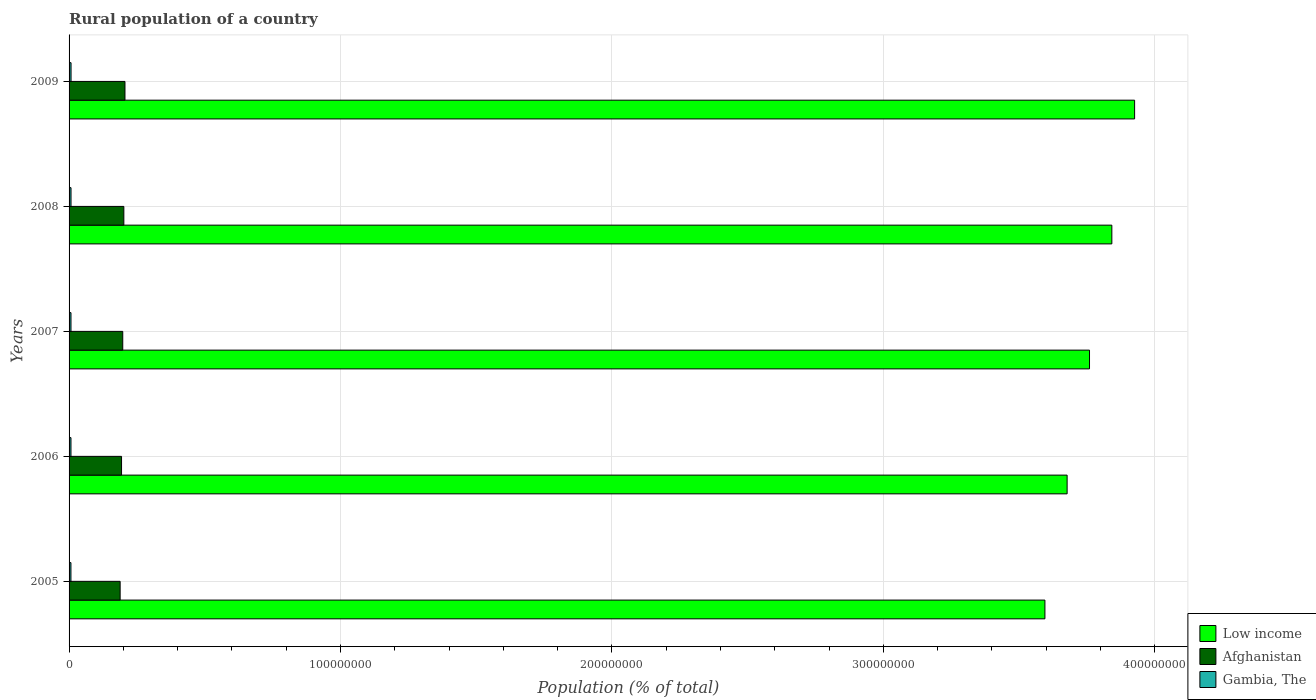How many groups of bars are there?
Your answer should be very brief. 5. Are the number of bars per tick equal to the number of legend labels?
Provide a short and direct response. Yes. Are the number of bars on each tick of the Y-axis equal?
Offer a terse response. Yes. How many bars are there on the 3rd tick from the top?
Keep it short and to the point. 3. How many bars are there on the 2nd tick from the bottom?
Keep it short and to the point. 3. What is the label of the 3rd group of bars from the top?
Your answer should be compact. 2007. What is the rural population in Gambia, The in 2007?
Your answer should be compact. 7.07e+05. Across all years, what is the maximum rural population in Gambia, The?
Keep it short and to the point. 7.28e+05. Across all years, what is the minimum rural population in Afghanistan?
Offer a very short reply. 1.88e+07. In which year was the rural population in Afghanistan minimum?
Provide a short and direct response. 2005. What is the total rural population in Low income in the graph?
Ensure brevity in your answer.  1.88e+09. What is the difference between the rural population in Gambia, The in 2006 and that in 2008?
Your answer should be compact. -2.09e+04. What is the difference between the rural population in Afghanistan in 2005 and the rural population in Low income in 2007?
Provide a short and direct response. -3.57e+08. What is the average rural population in Afghanistan per year?
Keep it short and to the point. 1.97e+07. In the year 2007, what is the difference between the rural population in Afghanistan and rural population in Gambia, The?
Provide a short and direct response. 1.91e+07. In how many years, is the rural population in Low income greater than 320000000 %?
Offer a terse response. 5. What is the ratio of the rural population in Gambia, The in 2006 to that in 2007?
Give a very brief answer. 0.99. Is the rural population in Low income in 2007 less than that in 2009?
Provide a succinct answer. Yes. Is the difference between the rural population in Afghanistan in 2006 and 2008 greater than the difference between the rural population in Gambia, The in 2006 and 2008?
Offer a very short reply. No. What is the difference between the highest and the second highest rural population in Afghanistan?
Give a very brief answer. 4.16e+05. What is the difference between the highest and the lowest rural population in Low income?
Ensure brevity in your answer.  3.30e+07. Is the sum of the rural population in Afghanistan in 2007 and 2009 greater than the maximum rural population in Low income across all years?
Provide a short and direct response. No. What does the 1st bar from the top in 2008 represents?
Give a very brief answer. Gambia, The. What does the 2nd bar from the bottom in 2008 represents?
Your response must be concise. Afghanistan. Is it the case that in every year, the sum of the rural population in Low income and rural population in Afghanistan is greater than the rural population in Gambia, The?
Keep it short and to the point. Yes. How many bars are there?
Make the answer very short. 15. Are all the bars in the graph horizontal?
Keep it short and to the point. Yes. How many years are there in the graph?
Your answer should be very brief. 5. Are the values on the major ticks of X-axis written in scientific E-notation?
Make the answer very short. No. Does the graph contain any zero values?
Offer a very short reply. No. Does the graph contain grids?
Give a very brief answer. Yes. How many legend labels are there?
Your answer should be very brief. 3. How are the legend labels stacked?
Offer a very short reply. Vertical. What is the title of the graph?
Give a very brief answer. Rural population of a country. Does "Fiji" appear as one of the legend labels in the graph?
Offer a terse response. No. What is the label or title of the X-axis?
Provide a succinct answer. Population (% of total). What is the Population (% of total) of Low income in 2005?
Ensure brevity in your answer.  3.60e+08. What is the Population (% of total) in Afghanistan in 2005?
Your response must be concise. 1.88e+07. What is the Population (% of total) in Gambia, The in 2005?
Make the answer very short. 6.87e+05. What is the Population (% of total) of Low income in 2006?
Give a very brief answer. 3.68e+08. What is the Population (% of total) in Afghanistan in 2006?
Ensure brevity in your answer.  1.93e+07. What is the Population (% of total) of Gambia, The in 2006?
Offer a terse response. 6.97e+05. What is the Population (% of total) in Low income in 2007?
Your answer should be very brief. 3.76e+08. What is the Population (% of total) in Afghanistan in 2007?
Ensure brevity in your answer.  1.98e+07. What is the Population (% of total) of Gambia, The in 2007?
Make the answer very short. 7.07e+05. What is the Population (% of total) of Low income in 2008?
Your answer should be compact. 3.84e+08. What is the Population (% of total) in Afghanistan in 2008?
Give a very brief answer. 2.02e+07. What is the Population (% of total) in Gambia, The in 2008?
Your answer should be very brief. 7.17e+05. What is the Population (% of total) of Low income in 2009?
Offer a very short reply. 3.93e+08. What is the Population (% of total) in Afghanistan in 2009?
Your answer should be compact. 2.06e+07. What is the Population (% of total) of Gambia, The in 2009?
Your response must be concise. 7.28e+05. Across all years, what is the maximum Population (% of total) in Low income?
Offer a terse response. 3.93e+08. Across all years, what is the maximum Population (% of total) of Afghanistan?
Provide a succinct answer. 2.06e+07. Across all years, what is the maximum Population (% of total) of Gambia, The?
Make the answer very short. 7.28e+05. Across all years, what is the minimum Population (% of total) of Low income?
Provide a succinct answer. 3.60e+08. Across all years, what is the minimum Population (% of total) of Afghanistan?
Provide a short and direct response. 1.88e+07. Across all years, what is the minimum Population (% of total) in Gambia, The?
Ensure brevity in your answer.  6.87e+05. What is the total Population (% of total) in Low income in the graph?
Provide a short and direct response. 1.88e+09. What is the total Population (% of total) of Afghanistan in the graph?
Ensure brevity in your answer.  9.87e+07. What is the total Population (% of total) of Gambia, The in the graph?
Provide a short and direct response. 3.54e+06. What is the difference between the Population (% of total) of Low income in 2005 and that in 2006?
Offer a terse response. -8.17e+06. What is the difference between the Population (% of total) of Afghanistan in 2005 and that in 2006?
Provide a succinct answer. -5.18e+05. What is the difference between the Population (% of total) in Gambia, The in 2005 and that in 2006?
Offer a terse response. -9992. What is the difference between the Population (% of total) of Low income in 2005 and that in 2007?
Your answer should be very brief. -1.64e+07. What is the difference between the Population (% of total) of Afghanistan in 2005 and that in 2007?
Give a very brief answer. -9.60e+05. What is the difference between the Population (% of total) of Gambia, The in 2005 and that in 2007?
Your answer should be compact. -2.03e+04. What is the difference between the Population (% of total) of Low income in 2005 and that in 2008?
Ensure brevity in your answer.  -2.47e+07. What is the difference between the Population (% of total) of Afghanistan in 2005 and that in 2008?
Your response must be concise. -1.36e+06. What is the difference between the Population (% of total) in Gambia, The in 2005 and that in 2008?
Provide a short and direct response. -3.09e+04. What is the difference between the Population (% of total) in Low income in 2005 and that in 2009?
Ensure brevity in your answer.  -3.30e+07. What is the difference between the Population (% of total) of Afghanistan in 2005 and that in 2009?
Make the answer very short. -1.78e+06. What is the difference between the Population (% of total) of Gambia, The in 2005 and that in 2009?
Your response must be concise. -4.19e+04. What is the difference between the Population (% of total) in Low income in 2006 and that in 2007?
Provide a short and direct response. -8.25e+06. What is the difference between the Population (% of total) of Afghanistan in 2006 and that in 2007?
Your answer should be very brief. -4.42e+05. What is the difference between the Population (% of total) of Gambia, The in 2006 and that in 2007?
Your answer should be compact. -1.03e+04. What is the difference between the Population (% of total) of Low income in 2006 and that in 2008?
Offer a very short reply. -1.65e+07. What is the difference between the Population (% of total) of Afghanistan in 2006 and that in 2008?
Ensure brevity in your answer.  -8.44e+05. What is the difference between the Population (% of total) in Gambia, The in 2006 and that in 2008?
Offer a very short reply. -2.09e+04. What is the difference between the Population (% of total) in Low income in 2006 and that in 2009?
Provide a succinct answer. -2.49e+07. What is the difference between the Population (% of total) of Afghanistan in 2006 and that in 2009?
Your answer should be compact. -1.26e+06. What is the difference between the Population (% of total) of Gambia, The in 2006 and that in 2009?
Your response must be concise. -3.19e+04. What is the difference between the Population (% of total) of Low income in 2007 and that in 2008?
Offer a very short reply. -8.23e+06. What is the difference between the Population (% of total) of Afghanistan in 2007 and that in 2008?
Your response must be concise. -4.02e+05. What is the difference between the Population (% of total) of Gambia, The in 2007 and that in 2008?
Provide a short and direct response. -1.06e+04. What is the difference between the Population (% of total) in Low income in 2007 and that in 2009?
Offer a terse response. -1.66e+07. What is the difference between the Population (% of total) in Afghanistan in 2007 and that in 2009?
Your answer should be very brief. -8.19e+05. What is the difference between the Population (% of total) in Gambia, The in 2007 and that in 2009?
Your answer should be very brief. -2.16e+04. What is the difference between the Population (% of total) in Low income in 2008 and that in 2009?
Offer a very short reply. -8.38e+06. What is the difference between the Population (% of total) in Afghanistan in 2008 and that in 2009?
Give a very brief answer. -4.16e+05. What is the difference between the Population (% of total) in Gambia, The in 2008 and that in 2009?
Your answer should be very brief. -1.10e+04. What is the difference between the Population (% of total) in Low income in 2005 and the Population (% of total) in Afghanistan in 2006?
Make the answer very short. 3.40e+08. What is the difference between the Population (% of total) in Low income in 2005 and the Population (% of total) in Gambia, The in 2006?
Ensure brevity in your answer.  3.59e+08. What is the difference between the Population (% of total) of Afghanistan in 2005 and the Population (% of total) of Gambia, The in 2006?
Offer a terse response. 1.81e+07. What is the difference between the Population (% of total) in Low income in 2005 and the Population (% of total) in Afghanistan in 2007?
Your response must be concise. 3.40e+08. What is the difference between the Population (% of total) in Low income in 2005 and the Population (% of total) in Gambia, The in 2007?
Make the answer very short. 3.59e+08. What is the difference between the Population (% of total) in Afghanistan in 2005 and the Population (% of total) in Gambia, The in 2007?
Make the answer very short. 1.81e+07. What is the difference between the Population (% of total) in Low income in 2005 and the Population (% of total) in Afghanistan in 2008?
Ensure brevity in your answer.  3.39e+08. What is the difference between the Population (% of total) of Low income in 2005 and the Population (% of total) of Gambia, The in 2008?
Keep it short and to the point. 3.59e+08. What is the difference between the Population (% of total) in Afghanistan in 2005 and the Population (% of total) in Gambia, The in 2008?
Make the answer very short. 1.81e+07. What is the difference between the Population (% of total) of Low income in 2005 and the Population (% of total) of Afghanistan in 2009?
Your answer should be very brief. 3.39e+08. What is the difference between the Population (% of total) of Low income in 2005 and the Population (% of total) of Gambia, The in 2009?
Give a very brief answer. 3.59e+08. What is the difference between the Population (% of total) of Afghanistan in 2005 and the Population (% of total) of Gambia, The in 2009?
Offer a terse response. 1.81e+07. What is the difference between the Population (% of total) of Low income in 2006 and the Population (% of total) of Afghanistan in 2007?
Your answer should be compact. 3.48e+08. What is the difference between the Population (% of total) in Low income in 2006 and the Population (% of total) in Gambia, The in 2007?
Your response must be concise. 3.67e+08. What is the difference between the Population (% of total) of Afghanistan in 2006 and the Population (% of total) of Gambia, The in 2007?
Give a very brief answer. 1.86e+07. What is the difference between the Population (% of total) in Low income in 2006 and the Population (% of total) in Afghanistan in 2008?
Provide a short and direct response. 3.48e+08. What is the difference between the Population (% of total) in Low income in 2006 and the Population (% of total) in Gambia, The in 2008?
Offer a very short reply. 3.67e+08. What is the difference between the Population (% of total) of Afghanistan in 2006 and the Population (% of total) of Gambia, The in 2008?
Keep it short and to the point. 1.86e+07. What is the difference between the Population (% of total) of Low income in 2006 and the Population (% of total) of Afghanistan in 2009?
Your response must be concise. 3.47e+08. What is the difference between the Population (% of total) in Low income in 2006 and the Population (% of total) in Gambia, The in 2009?
Keep it short and to the point. 3.67e+08. What is the difference between the Population (% of total) of Afghanistan in 2006 and the Population (% of total) of Gambia, The in 2009?
Your answer should be compact. 1.86e+07. What is the difference between the Population (% of total) in Low income in 2007 and the Population (% of total) in Afghanistan in 2008?
Provide a succinct answer. 3.56e+08. What is the difference between the Population (% of total) of Low income in 2007 and the Population (% of total) of Gambia, The in 2008?
Provide a short and direct response. 3.75e+08. What is the difference between the Population (% of total) of Afghanistan in 2007 and the Population (% of total) of Gambia, The in 2008?
Offer a very short reply. 1.91e+07. What is the difference between the Population (% of total) of Low income in 2007 and the Population (% of total) of Afghanistan in 2009?
Ensure brevity in your answer.  3.55e+08. What is the difference between the Population (% of total) of Low income in 2007 and the Population (% of total) of Gambia, The in 2009?
Offer a very short reply. 3.75e+08. What is the difference between the Population (% of total) of Afghanistan in 2007 and the Population (% of total) of Gambia, The in 2009?
Make the answer very short. 1.90e+07. What is the difference between the Population (% of total) in Low income in 2008 and the Population (% of total) in Afghanistan in 2009?
Keep it short and to the point. 3.64e+08. What is the difference between the Population (% of total) in Low income in 2008 and the Population (% of total) in Gambia, The in 2009?
Offer a terse response. 3.83e+08. What is the difference between the Population (% of total) in Afghanistan in 2008 and the Population (% of total) in Gambia, The in 2009?
Give a very brief answer. 1.94e+07. What is the average Population (% of total) in Low income per year?
Your answer should be compact. 3.76e+08. What is the average Population (% of total) in Afghanistan per year?
Offer a very short reply. 1.97e+07. What is the average Population (% of total) in Gambia, The per year?
Make the answer very short. 7.07e+05. In the year 2005, what is the difference between the Population (% of total) in Low income and Population (% of total) in Afghanistan?
Give a very brief answer. 3.41e+08. In the year 2005, what is the difference between the Population (% of total) of Low income and Population (% of total) of Gambia, The?
Give a very brief answer. 3.59e+08. In the year 2005, what is the difference between the Population (% of total) in Afghanistan and Population (% of total) in Gambia, The?
Provide a succinct answer. 1.81e+07. In the year 2006, what is the difference between the Population (% of total) in Low income and Population (% of total) in Afghanistan?
Your answer should be very brief. 3.48e+08. In the year 2006, what is the difference between the Population (% of total) of Low income and Population (% of total) of Gambia, The?
Ensure brevity in your answer.  3.67e+08. In the year 2006, what is the difference between the Population (% of total) of Afghanistan and Population (% of total) of Gambia, The?
Ensure brevity in your answer.  1.86e+07. In the year 2007, what is the difference between the Population (% of total) of Low income and Population (% of total) of Afghanistan?
Your answer should be very brief. 3.56e+08. In the year 2007, what is the difference between the Population (% of total) in Low income and Population (% of total) in Gambia, The?
Keep it short and to the point. 3.75e+08. In the year 2007, what is the difference between the Population (% of total) of Afghanistan and Population (% of total) of Gambia, The?
Keep it short and to the point. 1.91e+07. In the year 2008, what is the difference between the Population (% of total) of Low income and Population (% of total) of Afghanistan?
Keep it short and to the point. 3.64e+08. In the year 2008, what is the difference between the Population (% of total) of Low income and Population (% of total) of Gambia, The?
Provide a succinct answer. 3.83e+08. In the year 2008, what is the difference between the Population (% of total) in Afghanistan and Population (% of total) in Gambia, The?
Provide a short and direct response. 1.95e+07. In the year 2009, what is the difference between the Population (% of total) of Low income and Population (% of total) of Afghanistan?
Make the answer very short. 3.72e+08. In the year 2009, what is the difference between the Population (% of total) of Low income and Population (% of total) of Gambia, The?
Provide a succinct answer. 3.92e+08. In the year 2009, what is the difference between the Population (% of total) in Afghanistan and Population (% of total) in Gambia, The?
Your answer should be very brief. 1.99e+07. What is the ratio of the Population (% of total) in Low income in 2005 to that in 2006?
Ensure brevity in your answer.  0.98. What is the ratio of the Population (% of total) of Afghanistan in 2005 to that in 2006?
Your answer should be compact. 0.97. What is the ratio of the Population (% of total) in Gambia, The in 2005 to that in 2006?
Make the answer very short. 0.99. What is the ratio of the Population (% of total) in Low income in 2005 to that in 2007?
Your answer should be very brief. 0.96. What is the ratio of the Population (% of total) of Afghanistan in 2005 to that in 2007?
Provide a succinct answer. 0.95. What is the ratio of the Population (% of total) of Gambia, The in 2005 to that in 2007?
Offer a very short reply. 0.97. What is the ratio of the Population (% of total) of Low income in 2005 to that in 2008?
Make the answer very short. 0.94. What is the ratio of the Population (% of total) of Afghanistan in 2005 to that in 2008?
Your answer should be compact. 0.93. What is the ratio of the Population (% of total) of Low income in 2005 to that in 2009?
Offer a very short reply. 0.92. What is the ratio of the Population (% of total) in Afghanistan in 2005 to that in 2009?
Give a very brief answer. 0.91. What is the ratio of the Population (% of total) in Gambia, The in 2005 to that in 2009?
Your answer should be very brief. 0.94. What is the ratio of the Population (% of total) in Afghanistan in 2006 to that in 2007?
Give a very brief answer. 0.98. What is the ratio of the Population (% of total) in Gambia, The in 2006 to that in 2007?
Keep it short and to the point. 0.99. What is the ratio of the Population (% of total) of Low income in 2006 to that in 2008?
Your answer should be very brief. 0.96. What is the ratio of the Population (% of total) in Afghanistan in 2006 to that in 2008?
Your response must be concise. 0.96. What is the ratio of the Population (% of total) of Gambia, The in 2006 to that in 2008?
Make the answer very short. 0.97. What is the ratio of the Population (% of total) of Low income in 2006 to that in 2009?
Ensure brevity in your answer.  0.94. What is the ratio of the Population (% of total) of Afghanistan in 2006 to that in 2009?
Your answer should be very brief. 0.94. What is the ratio of the Population (% of total) in Gambia, The in 2006 to that in 2009?
Provide a short and direct response. 0.96. What is the ratio of the Population (% of total) in Low income in 2007 to that in 2008?
Your answer should be compact. 0.98. What is the ratio of the Population (% of total) of Afghanistan in 2007 to that in 2008?
Your response must be concise. 0.98. What is the ratio of the Population (% of total) in Gambia, The in 2007 to that in 2008?
Your answer should be very brief. 0.99. What is the ratio of the Population (% of total) in Low income in 2007 to that in 2009?
Ensure brevity in your answer.  0.96. What is the ratio of the Population (% of total) of Afghanistan in 2007 to that in 2009?
Make the answer very short. 0.96. What is the ratio of the Population (% of total) of Gambia, The in 2007 to that in 2009?
Offer a terse response. 0.97. What is the ratio of the Population (% of total) in Low income in 2008 to that in 2009?
Offer a terse response. 0.98. What is the ratio of the Population (% of total) in Afghanistan in 2008 to that in 2009?
Provide a short and direct response. 0.98. What is the ratio of the Population (% of total) in Gambia, The in 2008 to that in 2009?
Make the answer very short. 0.98. What is the difference between the highest and the second highest Population (% of total) of Low income?
Your answer should be very brief. 8.38e+06. What is the difference between the highest and the second highest Population (% of total) in Afghanistan?
Provide a short and direct response. 4.16e+05. What is the difference between the highest and the second highest Population (% of total) in Gambia, The?
Your answer should be very brief. 1.10e+04. What is the difference between the highest and the lowest Population (% of total) of Low income?
Your answer should be very brief. 3.30e+07. What is the difference between the highest and the lowest Population (% of total) in Afghanistan?
Your answer should be very brief. 1.78e+06. What is the difference between the highest and the lowest Population (% of total) in Gambia, The?
Keep it short and to the point. 4.19e+04. 